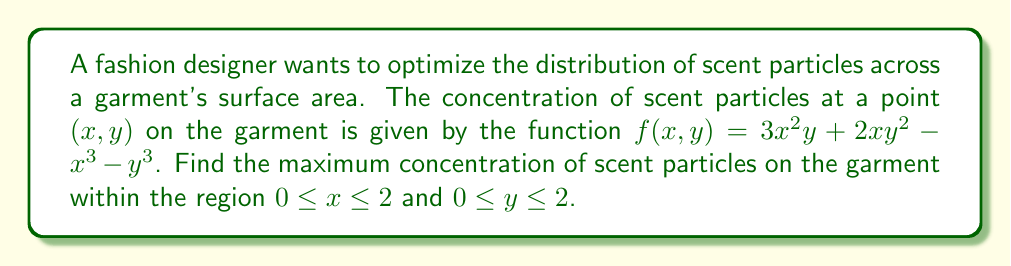Could you help me with this problem? To find the maximum concentration, we need to follow these steps:

1) First, we need to find the critical points by taking partial derivatives and setting them equal to zero:

   $$\frac{\partial f}{\partial x} = 6xy + 2y^2 - 3x^2 = 0$$
   $$\frac{\partial f}{\partial y} = 3x^2 + 4xy - 3y^2 = 0$$

2) Solving these equations simultaneously is complex, so we'll check the boundaries and corners of the region.

3) On the boundaries:
   - When $x = 0$: $f(0, y) = -y^3$
   - When $x = 2$: $f(2, y) = 12y + 2y^2 - 8 - y^3$
   - When $y = 0$: $f(x, 0) = -x^3$
   - When $y = 2$: $f(x, 2) = 12x + 8x - x^3 - 8$

4) At the corners:
   - $f(0, 0) = 0$
   - $f(2, 0) = -8$
   - $f(0, 2) = -8$
   - $f(2, 2) = 24 + 16 - 8 - 8 = 24$

5) To find the maximum on the boundary $x = 2$:
   $$\frac{d}{dy}f(2, y) = 12 + 4y - 3y^2 = 0$$
   Solving this, we get $y = 2$ or $y = -2/3$ (which is outside our region)

6) Similarly, for $y = 2$:
   $$\frac{d}{dx}f(x, 2) = 12 + 16 - 3x^2 = 0$$
   Solving this, we get $x = 2$ or $x = -2$ (which is outside our region)

7) The maximum value we've found is at the point (2, 2) with a value of 24.
Answer: 24 